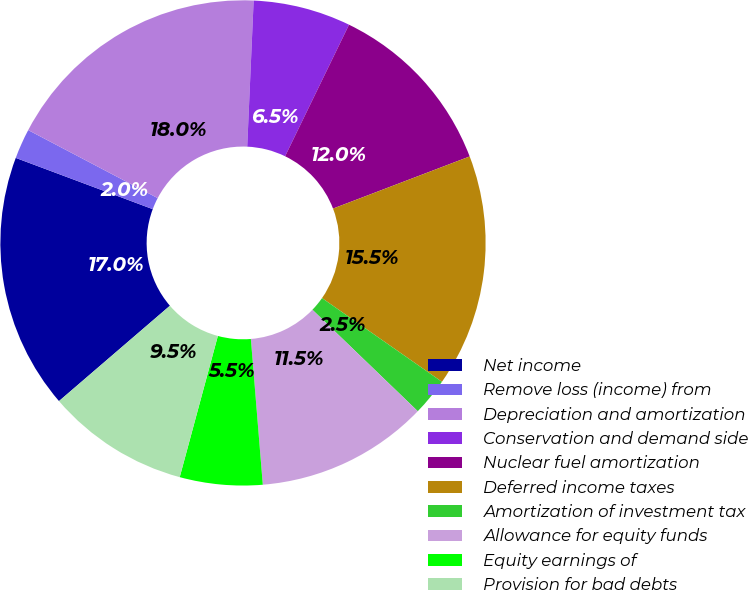<chart> <loc_0><loc_0><loc_500><loc_500><pie_chart><fcel>Net income<fcel>Remove loss (income) from<fcel>Depreciation and amortization<fcel>Conservation and demand side<fcel>Nuclear fuel amortization<fcel>Deferred income taxes<fcel>Amortization of investment tax<fcel>Allowance for equity funds<fcel>Equity earnings of<fcel>Provision for bad debts<nl><fcel>17.0%<fcel>2.0%<fcel>18.0%<fcel>6.5%<fcel>12.0%<fcel>15.5%<fcel>2.5%<fcel>11.5%<fcel>5.5%<fcel>9.5%<nl></chart> 